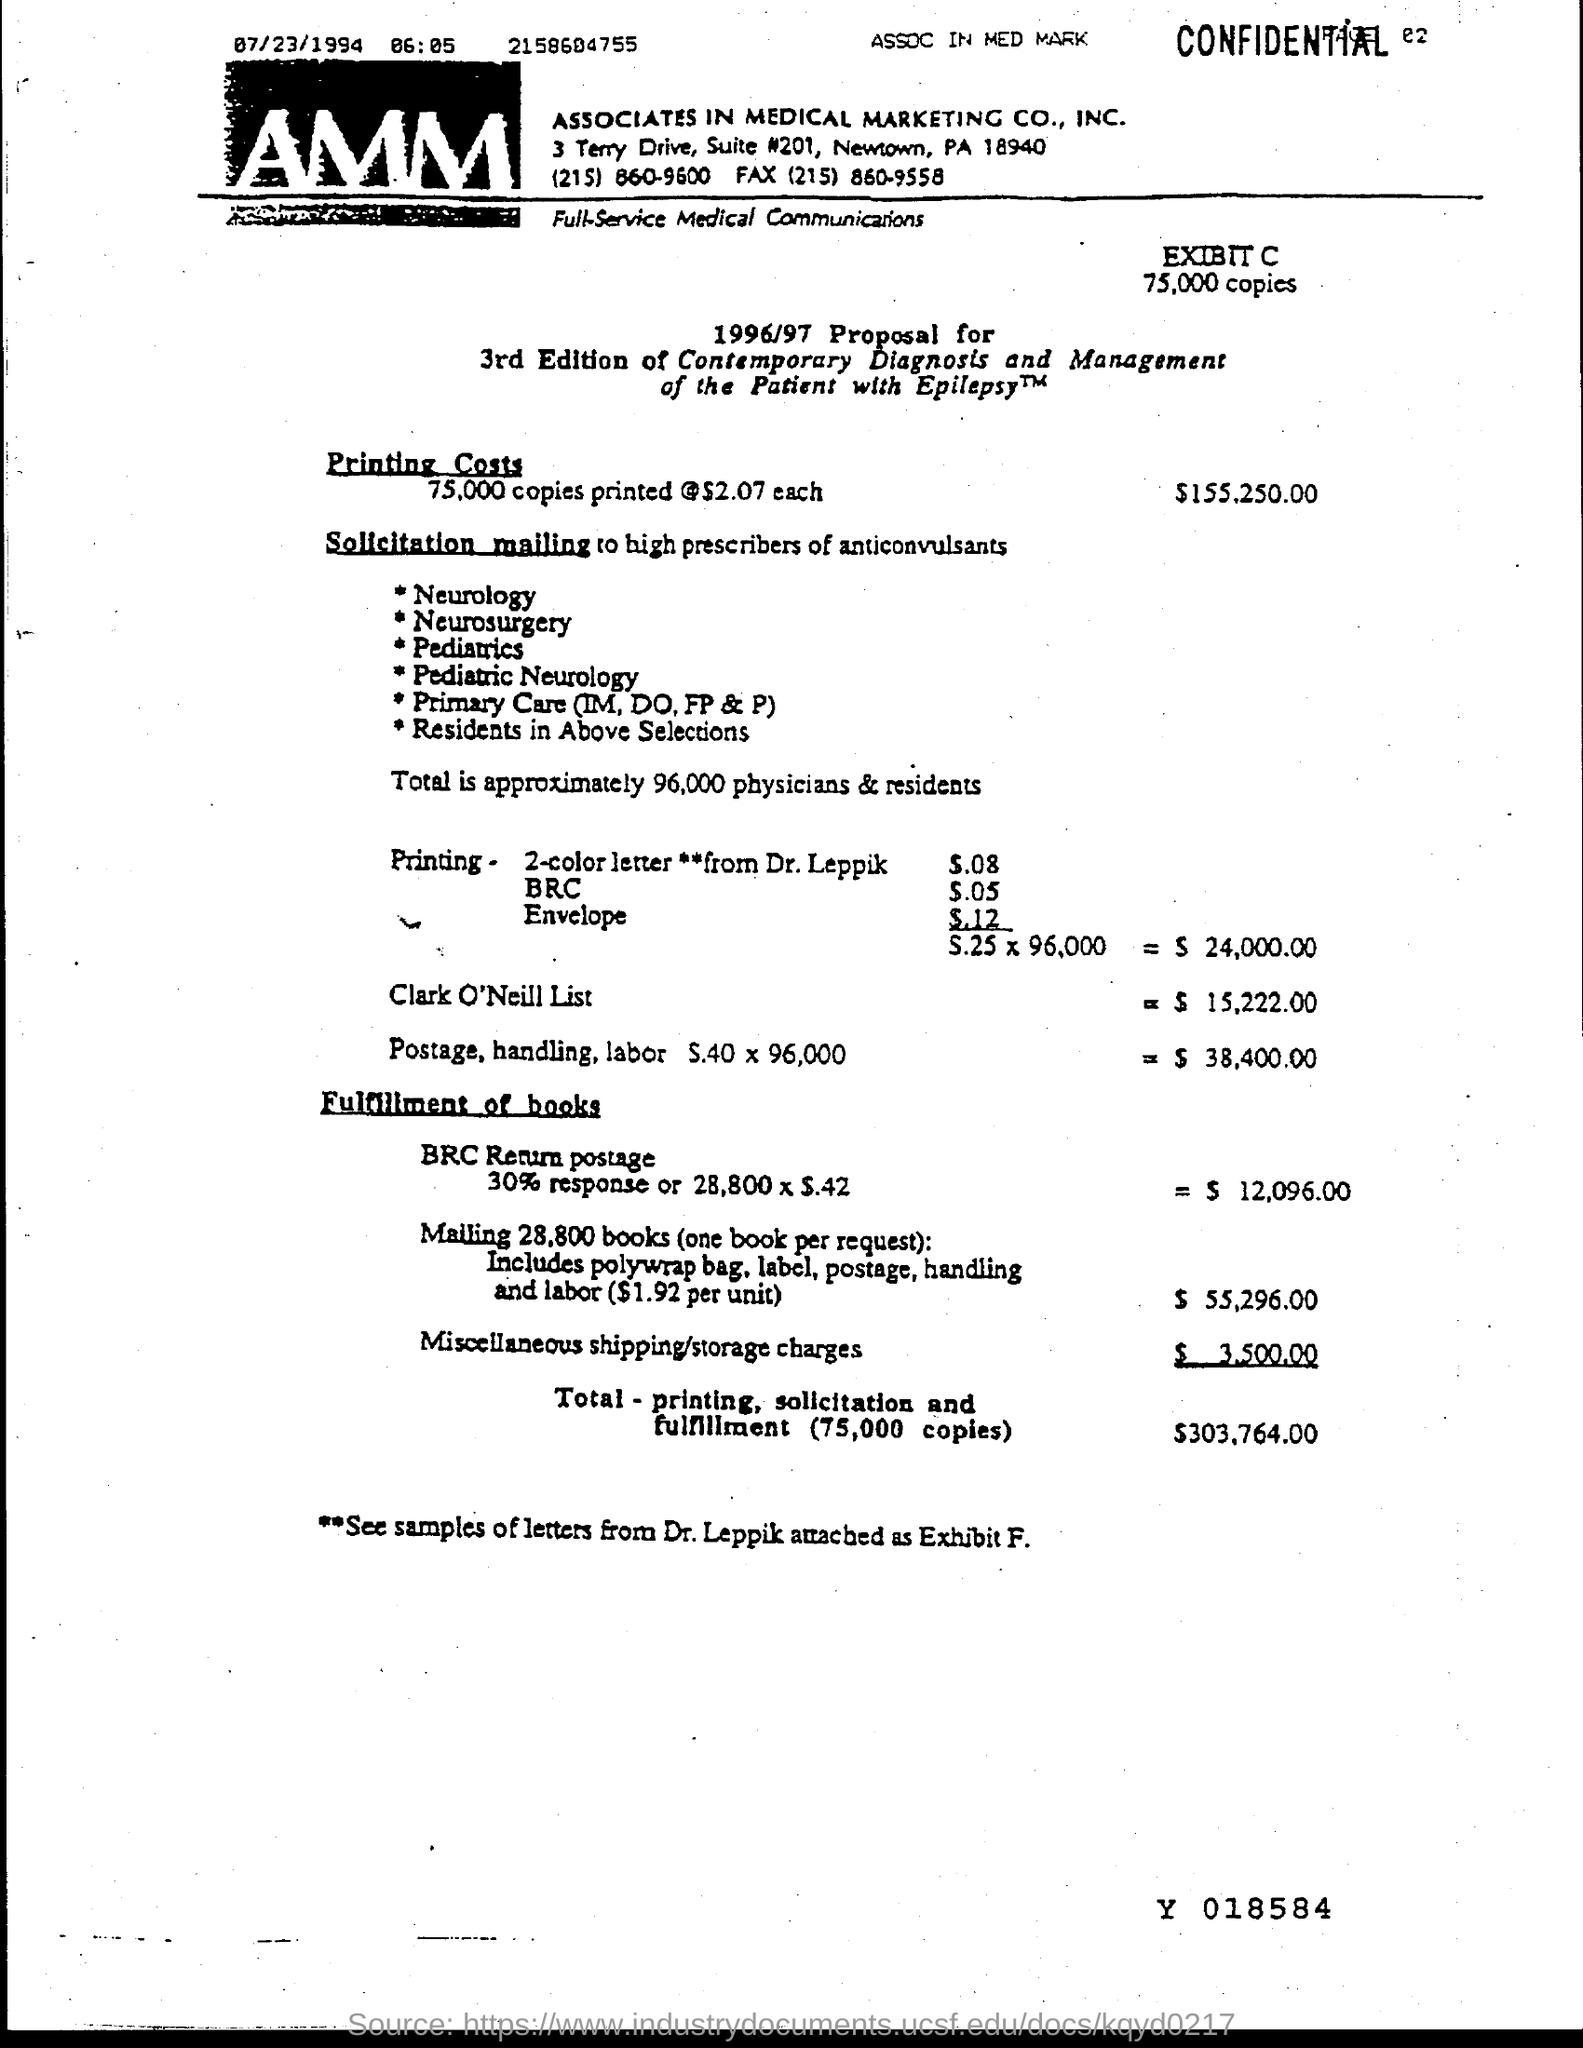In which city is associates in medical marketing co., inc. at?
Offer a very short reply. Newtown. What is total- printing, solicitation and fulfillment ( 75,000 copies) amount?
Provide a short and direct response. $303,764.00. 